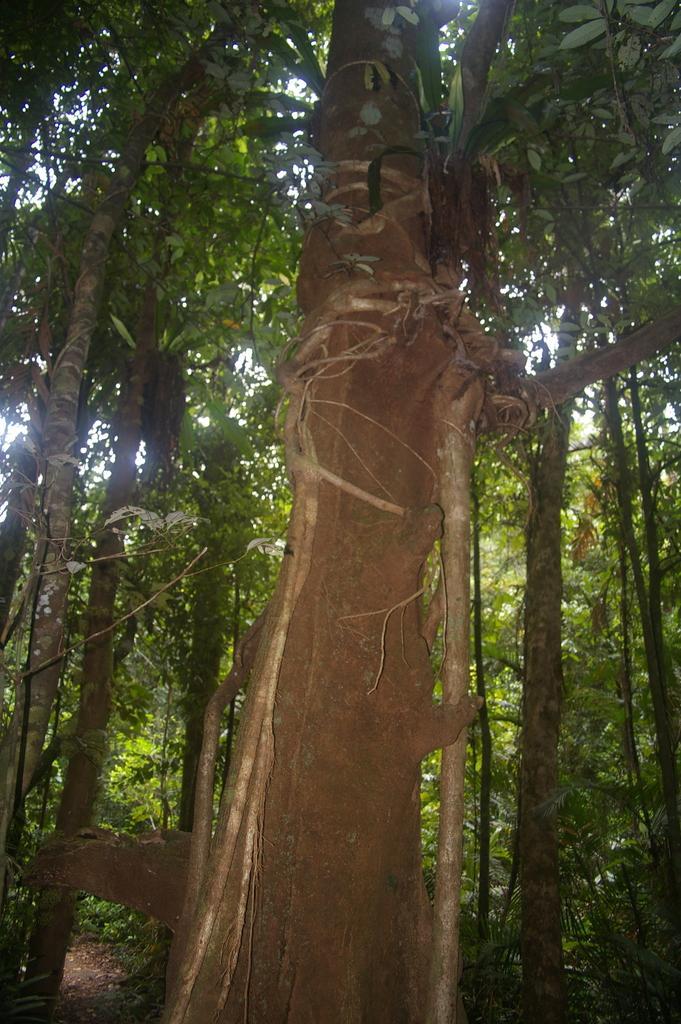Describe this image in one or two sentences. In this image, I can see a tree trunk. In the background, I can see the trees with branches and leaves. 